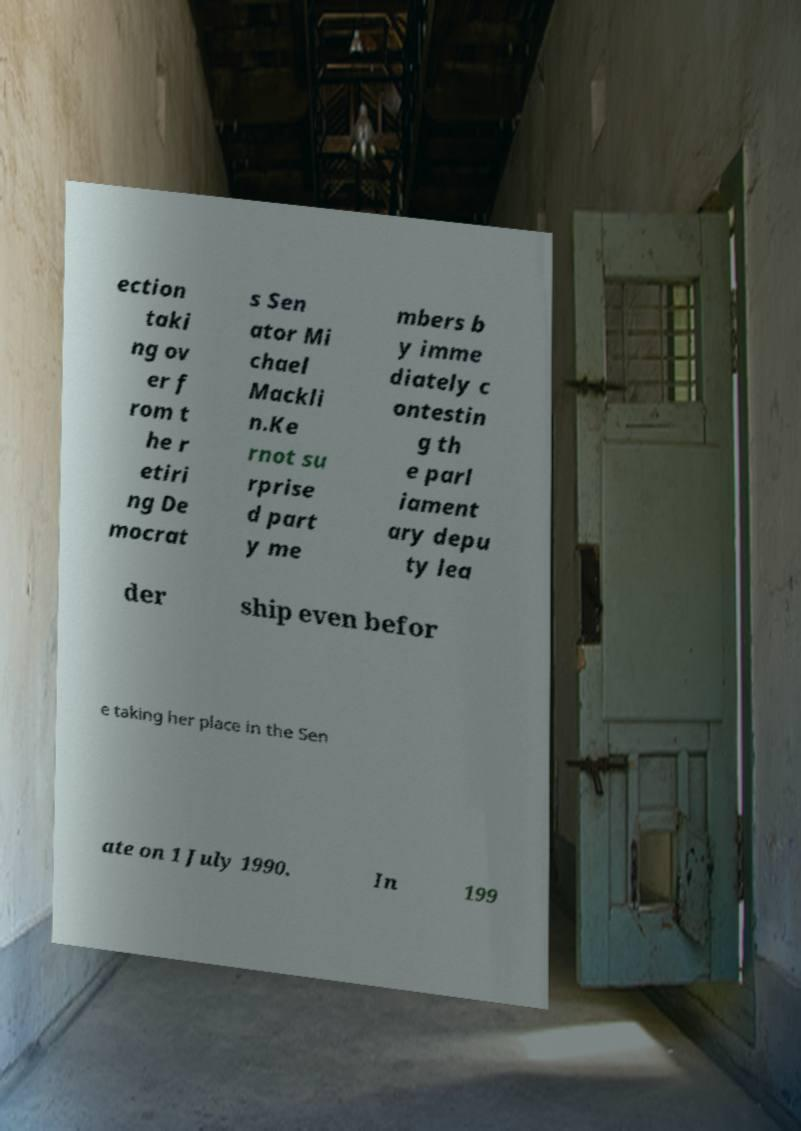Could you extract and type out the text from this image? ection taki ng ov er f rom t he r etiri ng De mocrat s Sen ator Mi chael Mackli n.Ke rnot su rprise d part y me mbers b y imme diately c ontestin g th e parl iament ary depu ty lea der ship even befor e taking her place in the Sen ate on 1 July 1990. In 199 